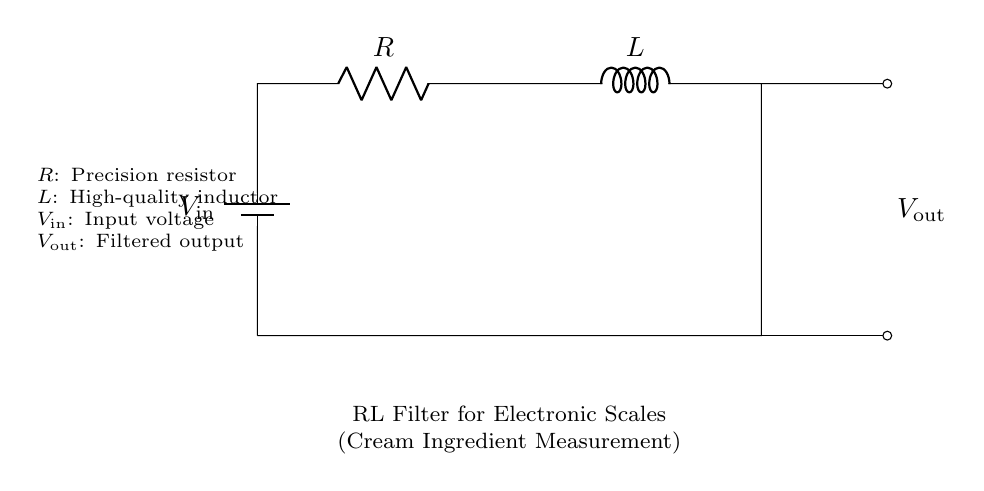What type of filter is represented in this circuit? The circuit represents an RL filter, which consists of a resistor and an inductor working together to filter signals. The 'RL' designation indicates this specific filter type.
Answer: RL filter What is the role of the inductor in this circuit? The inductor in this circuit is used to store energy in a magnetic field while also resisting changes in current. This characteristic helps smooth out changes in current, which is essential for creating a stable output.
Answer: Energy storage What are the components present in the circuit? The circuit has a battery, a resistor, and an inductor as its core components. The battery supplies the input voltage, while the resistor and inductor work together to filter and output a refined signal.
Answer: Battery, resistor, inductor How is the output voltage denoted in the circuit? The output voltage is denoted as V_out in the circuit. It is shown on the right side of the diagram, indicating where the filtered signal can be observed.
Answer: V_out What does the precision resistor help achieve in this RL filter? The precision resistor is critical for limiting current and determining the voltage drop in the circuit, contributing to the filter's overall performance and accuracy in ingredient measurement.
Answer: Current limiting What happens to the output voltage when the input voltage increases? When the input voltage increases, the output voltage will initially rise as well; however, due to the inductor's characteristics, the increase will be gradual as the inductor resists sudden changes in current. This results in a smooth response rather than a rapid spike.
Answer: Gradual increase How do the resistor and inductor interact in this circuit? The resistor and inductor interact by creating a specific time constant for the circuit, which dictates how quickly the circuit responds to changes in voltage. The resistor controls the current flow while the inductor stores energy, thus affecting the overall filtering process.
Answer: Create a time constant 